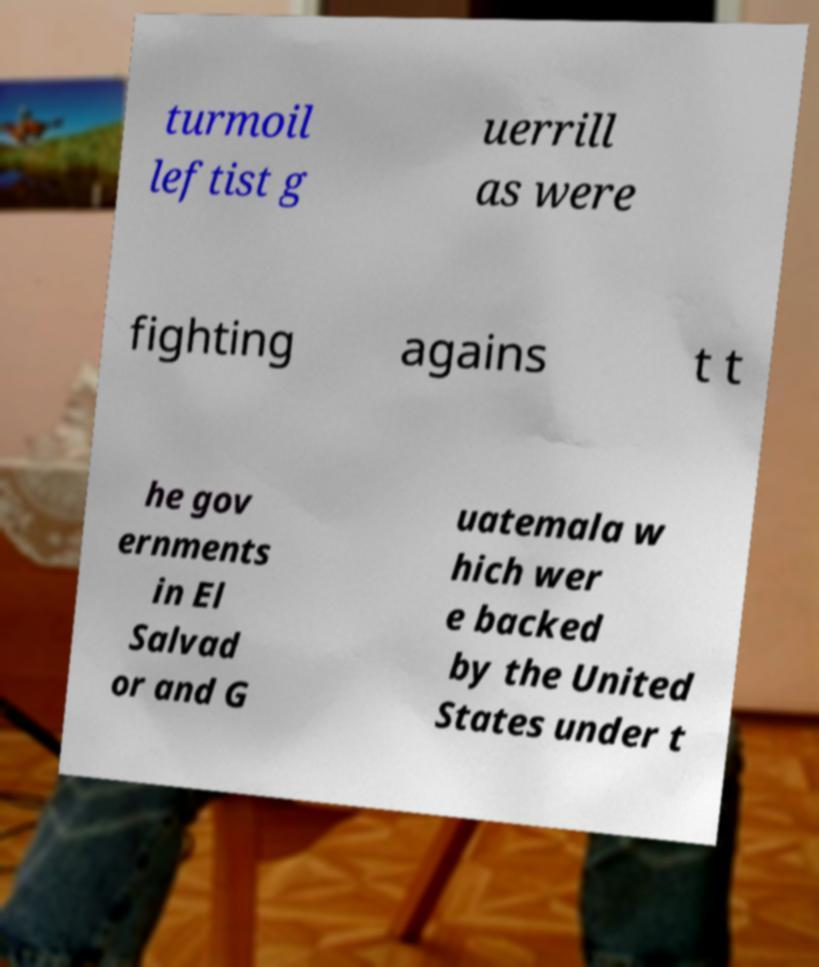For documentation purposes, I need the text within this image transcribed. Could you provide that? turmoil leftist g uerrill as were fighting agains t t he gov ernments in El Salvad or and G uatemala w hich wer e backed by the United States under t 